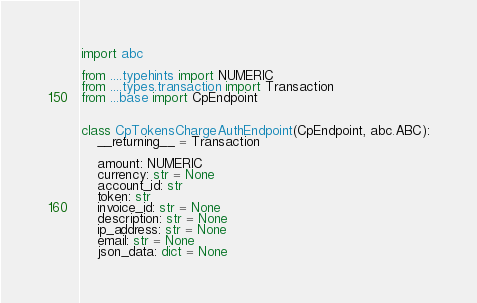Convert code to text. <code><loc_0><loc_0><loc_500><loc_500><_Python_>import abc

from ....typehints import NUMERIC
from ....types.transaction import Transaction
from ...base import CpEndpoint


class CpTokensChargeAuthEndpoint(CpEndpoint, abc.ABC):
    __returning__ = Transaction

    amount: NUMERIC
    currency: str = None
    account_id: str
    token: str
    invoice_id: str = None
    description: str = None
    ip_address: str = None
    email: str = None
    json_data: dict = None
</code> 